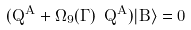Convert formula to latex. <formula><loc_0><loc_0><loc_500><loc_500>( Q ^ { A } + \Omega _ { 9 } ( \Gamma ) \ \tilde { Q } ^ { A } ) | B \rangle = 0</formula> 